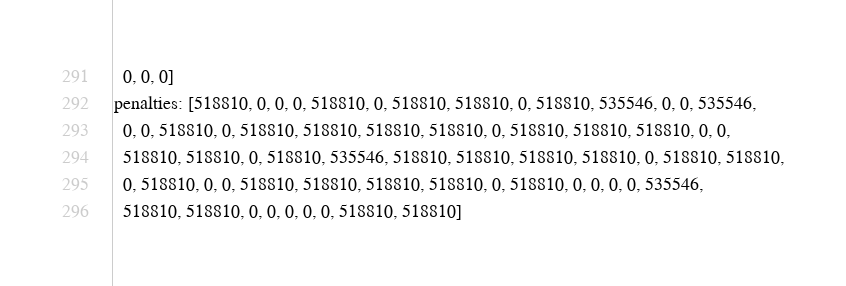Convert code to text. <code><loc_0><loc_0><loc_500><loc_500><_YAML_>  0, 0, 0]
penalties: [518810, 0, 0, 0, 518810, 0, 518810, 518810, 0, 518810, 535546, 0, 0, 535546,
  0, 0, 518810, 0, 518810, 518810, 518810, 518810, 0, 518810, 518810, 518810, 0, 0,
  518810, 518810, 0, 518810, 535546, 518810, 518810, 518810, 518810, 0, 518810, 518810,
  0, 518810, 0, 0, 518810, 518810, 518810, 518810, 0, 518810, 0, 0, 0, 0, 535546,
  518810, 518810, 0, 0, 0, 0, 0, 518810, 518810]
</code> 